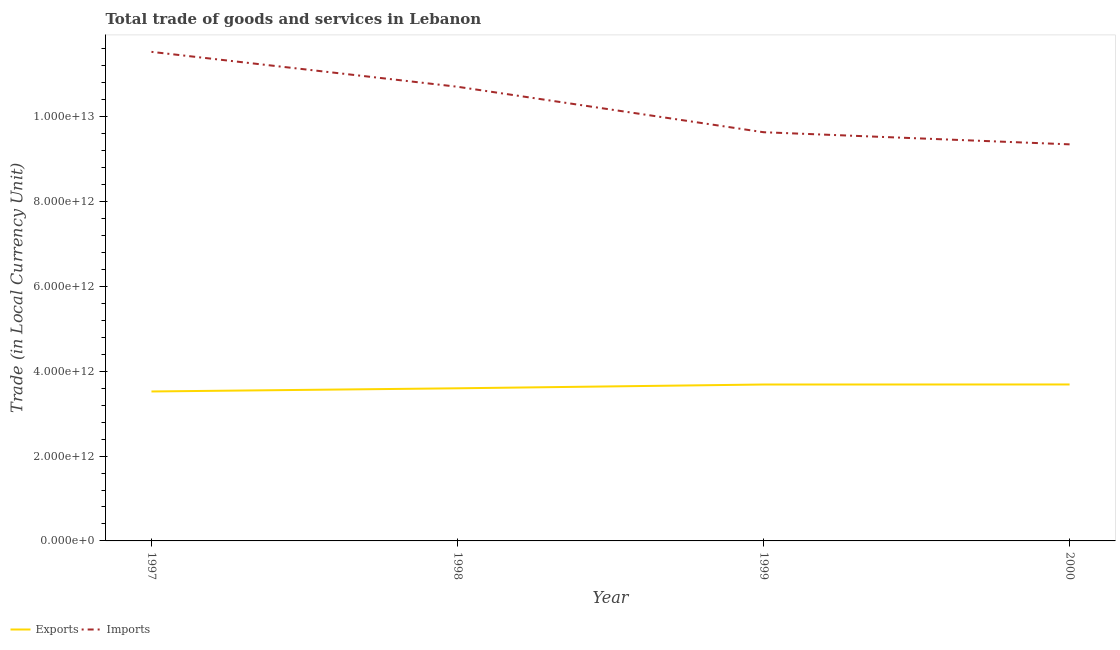How many different coloured lines are there?
Your response must be concise. 2. What is the imports of goods and services in 1999?
Keep it short and to the point. 9.64e+12. Across all years, what is the maximum imports of goods and services?
Your response must be concise. 1.15e+13. Across all years, what is the minimum export of goods and services?
Your response must be concise. 3.52e+12. What is the total imports of goods and services in the graph?
Offer a very short reply. 4.12e+13. What is the difference between the imports of goods and services in 1998 and that in 2000?
Give a very brief answer. 1.36e+12. What is the difference between the imports of goods and services in 1999 and the export of goods and services in 2000?
Provide a succinct answer. 5.95e+12. What is the average export of goods and services per year?
Make the answer very short. 3.62e+12. In the year 1997, what is the difference between the imports of goods and services and export of goods and services?
Your answer should be compact. 8.01e+12. In how many years, is the imports of goods and services greater than 4000000000000 LCU?
Provide a short and direct response. 4. What is the ratio of the imports of goods and services in 1997 to that in 1998?
Make the answer very short. 1.08. Is the imports of goods and services in 1997 less than that in 1998?
Give a very brief answer. No. What is the difference between the highest and the second highest imports of goods and services?
Your answer should be compact. 8.23e+11. What is the difference between the highest and the lowest imports of goods and services?
Your response must be concise. 2.18e+12. Is the sum of the export of goods and services in 1998 and 1999 greater than the maximum imports of goods and services across all years?
Offer a terse response. No. How many years are there in the graph?
Provide a succinct answer. 4. What is the difference between two consecutive major ticks on the Y-axis?
Provide a succinct answer. 2.00e+12. Are the values on the major ticks of Y-axis written in scientific E-notation?
Ensure brevity in your answer.  Yes. Does the graph contain any zero values?
Ensure brevity in your answer.  No. What is the title of the graph?
Offer a terse response. Total trade of goods and services in Lebanon. Does "GDP at market prices" appear as one of the legend labels in the graph?
Keep it short and to the point. No. What is the label or title of the Y-axis?
Offer a terse response. Trade (in Local Currency Unit). What is the Trade (in Local Currency Unit) in Exports in 1997?
Your response must be concise. 3.52e+12. What is the Trade (in Local Currency Unit) of Imports in 1997?
Make the answer very short. 1.15e+13. What is the Trade (in Local Currency Unit) in Exports in 1998?
Make the answer very short. 3.60e+12. What is the Trade (in Local Currency Unit) of Imports in 1998?
Ensure brevity in your answer.  1.07e+13. What is the Trade (in Local Currency Unit) in Exports in 1999?
Keep it short and to the point. 3.69e+12. What is the Trade (in Local Currency Unit) of Imports in 1999?
Give a very brief answer. 9.64e+12. What is the Trade (in Local Currency Unit) in Exports in 2000?
Offer a very short reply. 3.69e+12. What is the Trade (in Local Currency Unit) of Imports in 2000?
Your answer should be very brief. 9.35e+12. Across all years, what is the maximum Trade (in Local Currency Unit) in Exports?
Offer a terse response. 3.69e+12. Across all years, what is the maximum Trade (in Local Currency Unit) in Imports?
Make the answer very short. 1.15e+13. Across all years, what is the minimum Trade (in Local Currency Unit) in Exports?
Provide a succinct answer. 3.52e+12. Across all years, what is the minimum Trade (in Local Currency Unit) in Imports?
Your answer should be compact. 9.35e+12. What is the total Trade (in Local Currency Unit) in Exports in the graph?
Ensure brevity in your answer.  1.45e+13. What is the total Trade (in Local Currency Unit) in Imports in the graph?
Make the answer very short. 4.12e+13. What is the difference between the Trade (in Local Currency Unit) in Exports in 1997 and that in 1998?
Make the answer very short. -7.50e+1. What is the difference between the Trade (in Local Currency Unit) of Imports in 1997 and that in 1998?
Make the answer very short. 8.23e+11. What is the difference between the Trade (in Local Currency Unit) in Exports in 1997 and that in 1999?
Your response must be concise. -1.64e+11. What is the difference between the Trade (in Local Currency Unit) of Imports in 1997 and that in 1999?
Your answer should be very brief. 1.90e+12. What is the difference between the Trade (in Local Currency Unit) in Exports in 1997 and that in 2000?
Offer a very short reply. -1.65e+11. What is the difference between the Trade (in Local Currency Unit) of Imports in 1997 and that in 2000?
Provide a succinct answer. 2.18e+12. What is the difference between the Trade (in Local Currency Unit) of Exports in 1998 and that in 1999?
Provide a succinct answer. -8.90e+1. What is the difference between the Trade (in Local Currency Unit) of Imports in 1998 and that in 1999?
Provide a succinct answer. 1.07e+12. What is the difference between the Trade (in Local Currency Unit) of Exports in 1998 and that in 2000?
Your response must be concise. -9.00e+1. What is the difference between the Trade (in Local Currency Unit) in Imports in 1998 and that in 2000?
Offer a terse response. 1.36e+12. What is the difference between the Trade (in Local Currency Unit) of Exports in 1999 and that in 2000?
Make the answer very short. -1.00e+09. What is the difference between the Trade (in Local Currency Unit) of Imports in 1999 and that in 2000?
Your answer should be very brief. 2.86e+11. What is the difference between the Trade (in Local Currency Unit) of Exports in 1997 and the Trade (in Local Currency Unit) of Imports in 1998?
Ensure brevity in your answer.  -7.18e+12. What is the difference between the Trade (in Local Currency Unit) in Exports in 1997 and the Trade (in Local Currency Unit) in Imports in 1999?
Ensure brevity in your answer.  -6.11e+12. What is the difference between the Trade (in Local Currency Unit) of Exports in 1997 and the Trade (in Local Currency Unit) of Imports in 2000?
Ensure brevity in your answer.  -5.83e+12. What is the difference between the Trade (in Local Currency Unit) in Exports in 1998 and the Trade (in Local Currency Unit) in Imports in 1999?
Provide a succinct answer. -6.04e+12. What is the difference between the Trade (in Local Currency Unit) in Exports in 1998 and the Trade (in Local Currency Unit) in Imports in 2000?
Provide a succinct answer. -5.75e+12. What is the difference between the Trade (in Local Currency Unit) in Exports in 1999 and the Trade (in Local Currency Unit) in Imports in 2000?
Your answer should be compact. -5.66e+12. What is the average Trade (in Local Currency Unit) in Exports per year?
Provide a short and direct response. 3.62e+12. What is the average Trade (in Local Currency Unit) of Imports per year?
Give a very brief answer. 1.03e+13. In the year 1997, what is the difference between the Trade (in Local Currency Unit) of Exports and Trade (in Local Currency Unit) of Imports?
Keep it short and to the point. -8.01e+12. In the year 1998, what is the difference between the Trade (in Local Currency Unit) of Exports and Trade (in Local Currency Unit) of Imports?
Give a very brief answer. -7.11e+12. In the year 1999, what is the difference between the Trade (in Local Currency Unit) in Exports and Trade (in Local Currency Unit) in Imports?
Provide a short and direct response. -5.95e+12. In the year 2000, what is the difference between the Trade (in Local Currency Unit) of Exports and Trade (in Local Currency Unit) of Imports?
Make the answer very short. -5.66e+12. What is the ratio of the Trade (in Local Currency Unit) of Exports in 1997 to that in 1998?
Provide a succinct answer. 0.98. What is the ratio of the Trade (in Local Currency Unit) in Imports in 1997 to that in 1998?
Your answer should be very brief. 1.08. What is the ratio of the Trade (in Local Currency Unit) of Exports in 1997 to that in 1999?
Your answer should be compact. 0.96. What is the ratio of the Trade (in Local Currency Unit) in Imports in 1997 to that in 1999?
Provide a succinct answer. 1.2. What is the ratio of the Trade (in Local Currency Unit) of Exports in 1997 to that in 2000?
Ensure brevity in your answer.  0.96. What is the ratio of the Trade (in Local Currency Unit) of Imports in 1997 to that in 2000?
Your response must be concise. 1.23. What is the ratio of the Trade (in Local Currency Unit) in Exports in 1998 to that in 1999?
Keep it short and to the point. 0.98. What is the ratio of the Trade (in Local Currency Unit) in Imports in 1998 to that in 1999?
Your answer should be compact. 1.11. What is the ratio of the Trade (in Local Currency Unit) in Exports in 1998 to that in 2000?
Offer a terse response. 0.98. What is the ratio of the Trade (in Local Currency Unit) in Imports in 1998 to that in 2000?
Provide a succinct answer. 1.15. What is the ratio of the Trade (in Local Currency Unit) of Exports in 1999 to that in 2000?
Your response must be concise. 1. What is the ratio of the Trade (in Local Currency Unit) in Imports in 1999 to that in 2000?
Offer a very short reply. 1.03. What is the difference between the highest and the second highest Trade (in Local Currency Unit) of Imports?
Offer a very short reply. 8.23e+11. What is the difference between the highest and the lowest Trade (in Local Currency Unit) in Exports?
Your answer should be very brief. 1.65e+11. What is the difference between the highest and the lowest Trade (in Local Currency Unit) in Imports?
Provide a succinct answer. 2.18e+12. 